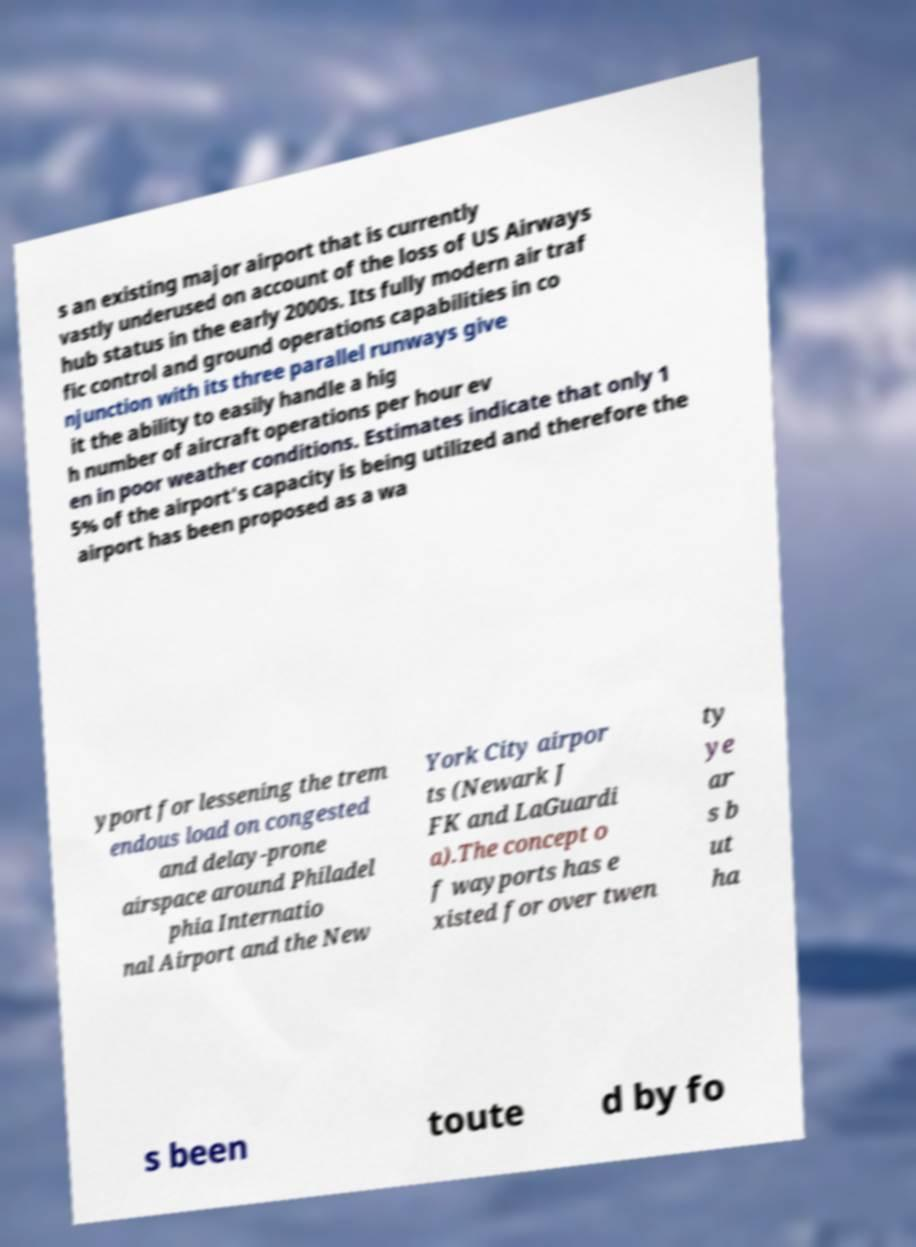Could you extract and type out the text from this image? s an existing major airport that is currently vastly underused on account of the loss of US Airways hub status in the early 2000s. Its fully modern air traf fic control and ground operations capabilities in co njunction with its three parallel runways give it the ability to easily handle a hig h number of aircraft operations per hour ev en in poor weather conditions. Estimates indicate that only 1 5% of the airport's capacity is being utilized and therefore the airport has been proposed as a wa yport for lessening the trem endous load on congested and delay-prone airspace around Philadel phia Internatio nal Airport and the New York City airpor ts (Newark J FK and LaGuardi a).The concept o f wayports has e xisted for over twen ty ye ar s b ut ha s been toute d by fo 